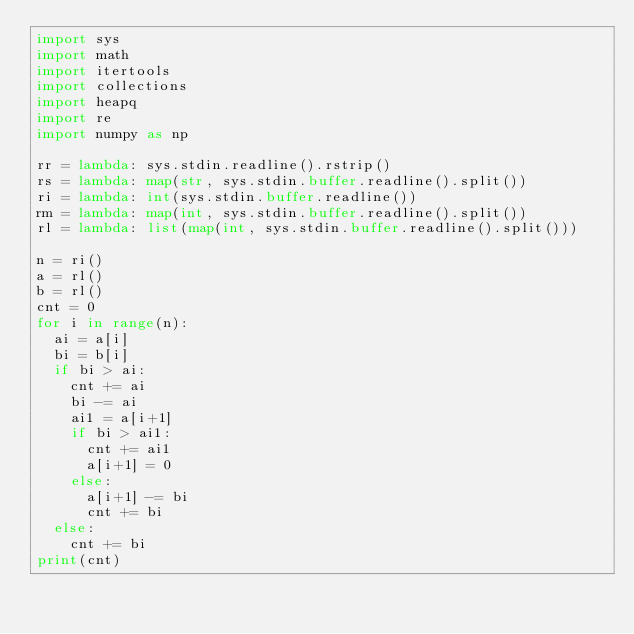<code> <loc_0><loc_0><loc_500><loc_500><_Python_>import sys
import math
import itertools
import collections
import heapq
import re
import numpy as np

rr = lambda: sys.stdin.readline().rstrip()
rs = lambda: map(str, sys.stdin.buffer.readline().split())
ri = lambda: int(sys.stdin.buffer.readline())
rm = lambda: map(int, sys.stdin.buffer.readline().split())
rl = lambda: list(map(int, sys.stdin.buffer.readline().split()))

n = ri()
a = rl()
b = rl()
cnt = 0
for i in range(n):
  ai = a[i]
  bi = b[i]
  if bi > ai:
    cnt += ai
    bi -= ai
    ai1 = a[i+1]
    if bi > ai1:
      cnt += ai1
      a[i+1] = 0
    else:
      a[i+1] -= bi
      cnt += bi
  else:
    cnt += bi
print(cnt)



</code> 